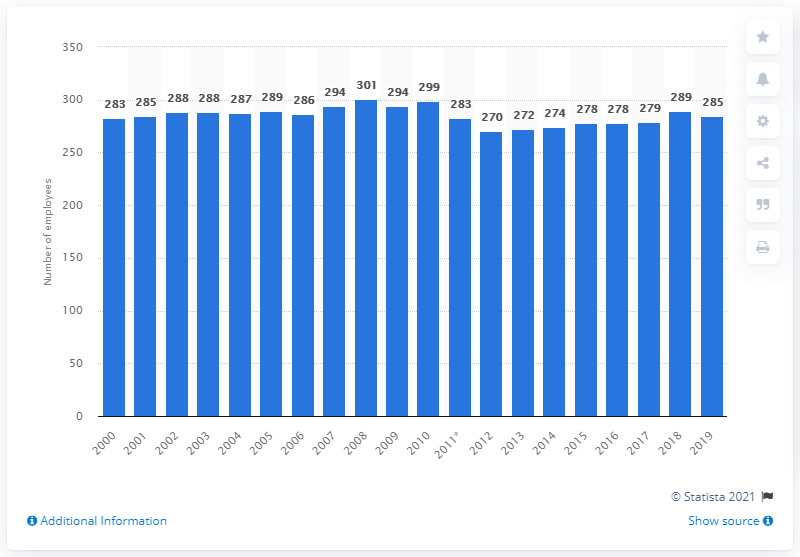Identify some key points in this picture. In 2019, there were 285 dentists who were employed in Iceland. In 2008, there were 301 dentists employed in Iceland. 